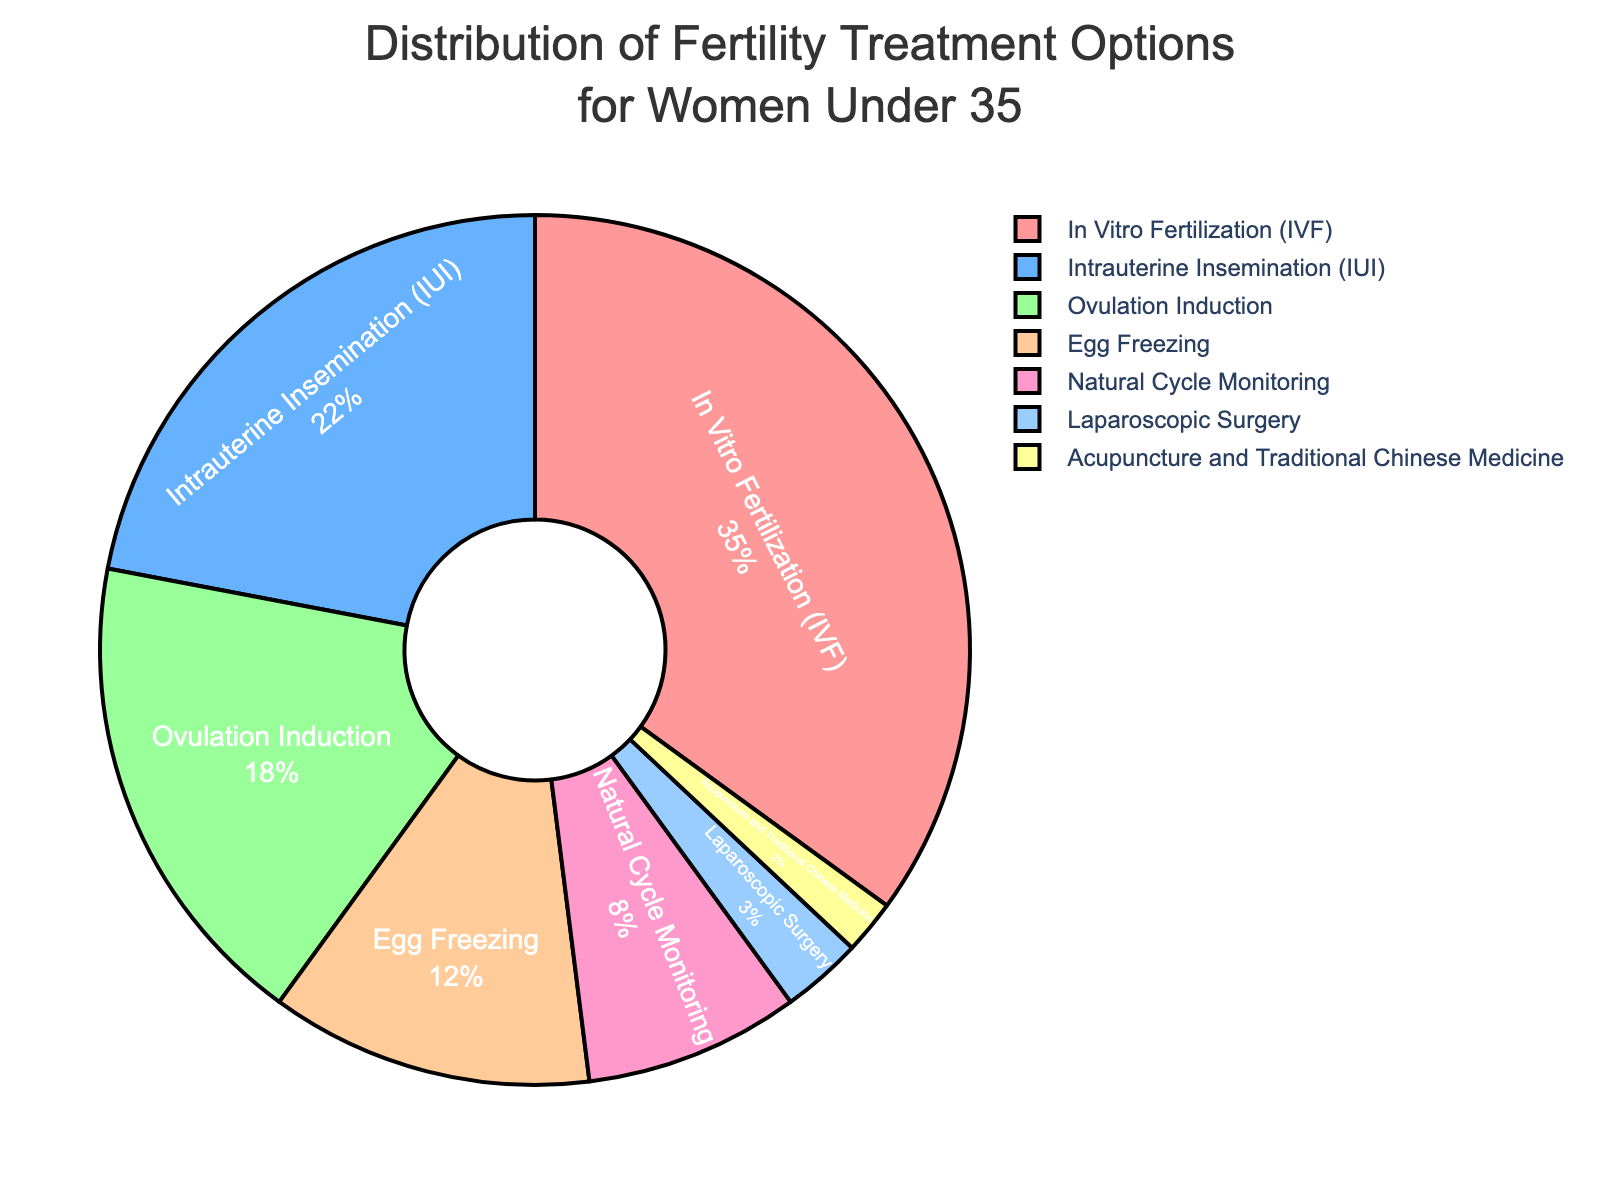What is the most commonly chosen fertility treatment option? The slice for "In Vitro Fertilization (IVF)" occupies the largest portion of the pie chart compared to the other treatments.
Answer: In Vitro Fertilization (IVF) What percentage of women under 35 choose Intrauterine Insemination (IUI)? The pie chart shows the section labeled "Intrauterine Insemination (IUI)" with its percentage directly on the graph.
Answer: 22% How does the percentage of women opting for Ovulation Induction compare to Egg Freezing? According to the pie chart, Ovulation Induction has a value of 18%, whereas Egg Freezing has a value of 12%. 18% is greater than 12%.
Answer: Ovulation Induction is higher What is the combined percentage of women choosing Laparoscopic Surgery and Acupuncture and Traditional Chinese Medicine? Add the percentages for Laparoscopic Surgery (3%) and Acupuncture and Traditional Chinese Medicine (2%). 3% + 2% = 5%.
Answer: 5% Which option has a smaller percentage: Natural Cycle Monitoring or Egg Freezing? Based on the pie chart, Natural Cycle Monitoring occupies 8% while Egg Freezing occupies 12%. 8% is smaller than 12%.
Answer: Natural Cycle Monitoring What percentage of women chose treatments other than In Vitro Fertilization (IVF)? Subtract the percentage for In Vitro Fertilization (IVF) from 100%. 100% - 35% = 65%.
Answer: 65% What is the total percentage of women opting for non-medical treatments (Acupuncture and Traditional Chinese Medicine)? The pie chart shows only one non-medical option, Acupuncture and Traditional Chinese Medicine, which accounts for 2%.
Answer: 2% Are there more women choosing Ovulation Induction than Natural Cycle Monitoring? Comparing the percentages in the pie chart, Ovulation Induction is at 18%, and Natural Cycle Monitoring is at 8%. 18% is greater than 8%.
Answer: Yes Which treatments have a percentage less than 10%? The pie chart shows that Natural Cycle Monitoring (8%), Laparoscopic Surgery (3%), and Acupuncture and Traditional Chinese Medicine (2%) all have percentages less than 10%.
Answer: Natural Cycle Monitoring, Laparoscopic Surgery, Acupuncture and Traditional Chinese Medicine What is the difference in percentage between the most chosen and least chosen treatments? The percentage for the most chosen treatment (In Vitro Fertilization - 35%) minus the percentage for the least chosen treatment (Acupuncture and Traditional Chinese Medicine - 2%). 35% - 2% = 33%.
Answer: 33% 